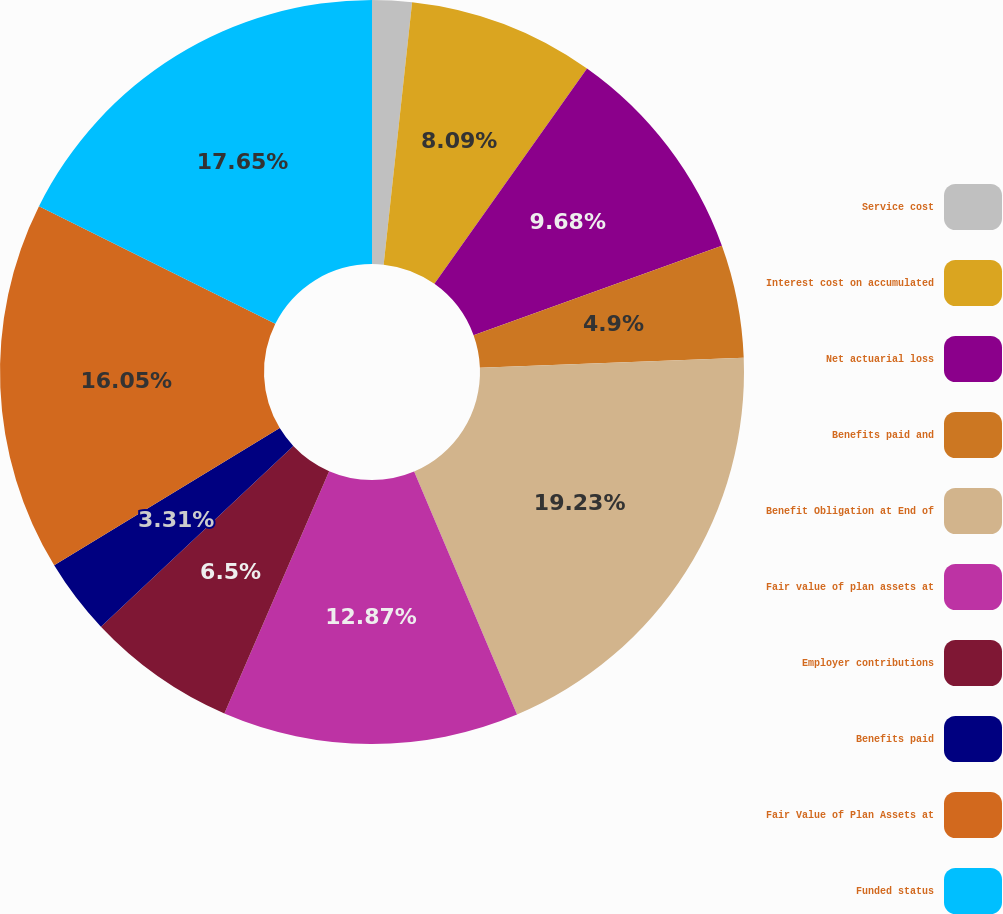Convert chart to OTSL. <chart><loc_0><loc_0><loc_500><loc_500><pie_chart><fcel>Service cost<fcel>Interest cost on accumulated<fcel>Net actuarial loss<fcel>Benefits paid and<fcel>Benefit Obligation at End of<fcel>Fair value of plan assets at<fcel>Employer contributions<fcel>Benefits paid<fcel>Fair Value of Plan Assets at<fcel>Funded status<nl><fcel>1.72%<fcel>8.09%<fcel>9.68%<fcel>4.9%<fcel>19.24%<fcel>12.87%<fcel>6.5%<fcel>3.31%<fcel>16.05%<fcel>17.65%<nl></chart> 